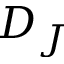<formula> <loc_0><loc_0><loc_500><loc_500>D _ { J }</formula> 